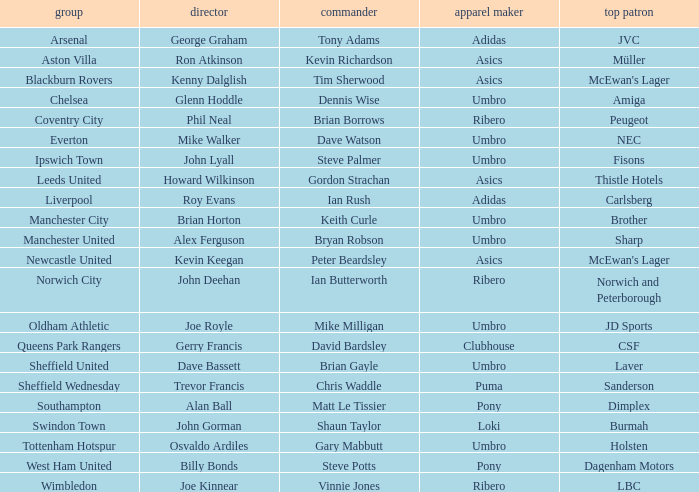Which manager has Manchester City as the team? Brian Horton. Help me parse the entirety of this table. {'header': ['group', 'director', 'commander', 'apparel maker', 'top patron'], 'rows': [['Arsenal', 'George Graham', 'Tony Adams', 'Adidas', 'JVC'], ['Aston Villa', 'Ron Atkinson', 'Kevin Richardson', 'Asics', 'Müller'], ['Blackburn Rovers', 'Kenny Dalglish', 'Tim Sherwood', 'Asics', "McEwan's Lager"], ['Chelsea', 'Glenn Hoddle', 'Dennis Wise', 'Umbro', 'Amiga'], ['Coventry City', 'Phil Neal', 'Brian Borrows', 'Ribero', 'Peugeot'], ['Everton', 'Mike Walker', 'Dave Watson', 'Umbro', 'NEC'], ['Ipswich Town', 'John Lyall', 'Steve Palmer', 'Umbro', 'Fisons'], ['Leeds United', 'Howard Wilkinson', 'Gordon Strachan', 'Asics', 'Thistle Hotels'], ['Liverpool', 'Roy Evans', 'Ian Rush', 'Adidas', 'Carlsberg'], ['Manchester City', 'Brian Horton', 'Keith Curle', 'Umbro', 'Brother'], ['Manchester United', 'Alex Ferguson', 'Bryan Robson', 'Umbro', 'Sharp'], ['Newcastle United', 'Kevin Keegan', 'Peter Beardsley', 'Asics', "McEwan's Lager"], ['Norwich City', 'John Deehan', 'Ian Butterworth', 'Ribero', 'Norwich and Peterborough'], ['Oldham Athletic', 'Joe Royle', 'Mike Milligan', 'Umbro', 'JD Sports'], ['Queens Park Rangers', 'Gerry Francis', 'David Bardsley', 'Clubhouse', 'CSF'], ['Sheffield United', 'Dave Bassett', 'Brian Gayle', 'Umbro', 'Laver'], ['Sheffield Wednesday', 'Trevor Francis', 'Chris Waddle', 'Puma', 'Sanderson'], ['Southampton', 'Alan Ball', 'Matt Le Tissier', 'Pony', 'Dimplex'], ['Swindon Town', 'John Gorman', 'Shaun Taylor', 'Loki', 'Burmah'], ['Tottenham Hotspur', 'Osvaldo Ardiles', 'Gary Mabbutt', 'Umbro', 'Holsten'], ['West Ham United', 'Billy Bonds', 'Steve Potts', 'Pony', 'Dagenham Motors'], ['Wimbledon', 'Joe Kinnear', 'Vinnie Jones', 'Ribero', 'LBC']]} 